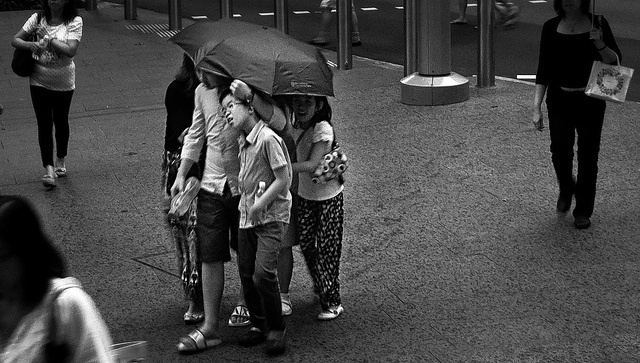Describe the objects in this image and their specific colors. I can see people in black, gray, darkgray, and lightgray tones, people in black, gray, and lightgray tones, people in black, gray, darkgray, and lightgray tones, people in black, gray, darkgray, and lightgray tones, and people in black, gray, darkgray, and lightgray tones in this image. 